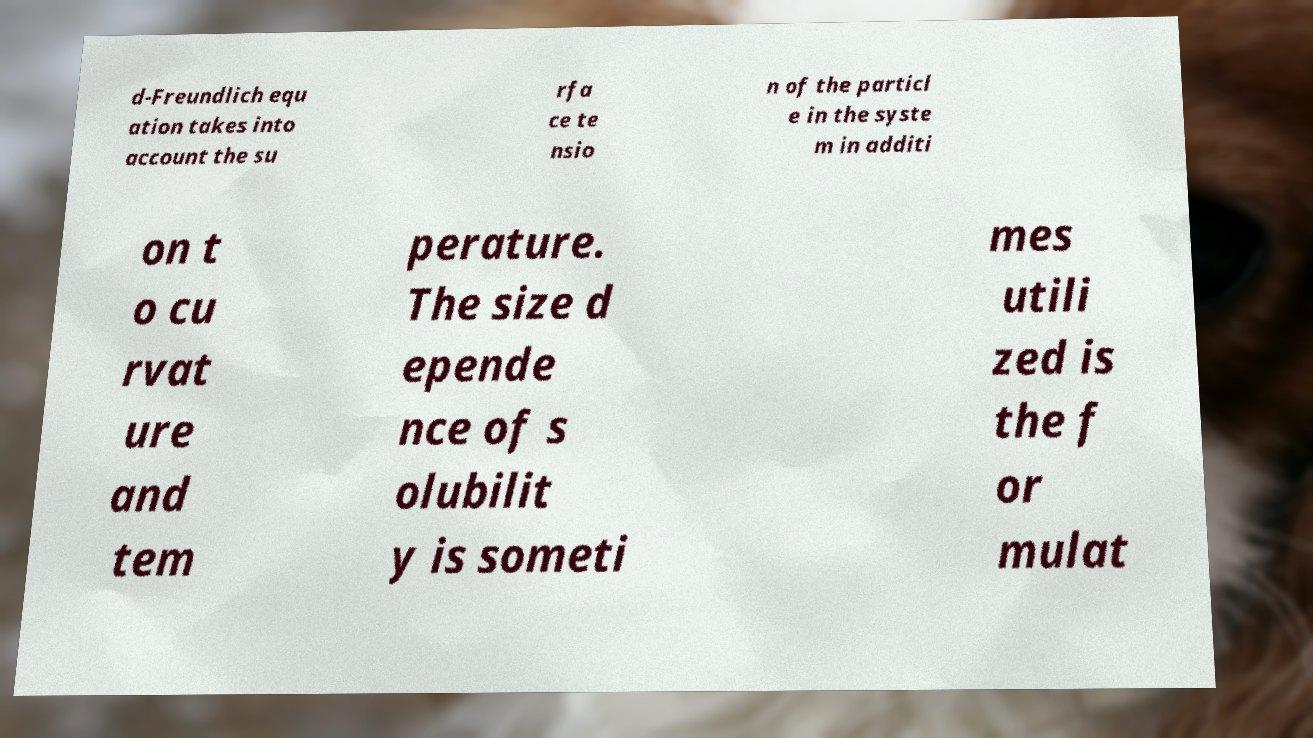Could you assist in decoding the text presented in this image and type it out clearly? d-Freundlich equ ation takes into account the su rfa ce te nsio n of the particl e in the syste m in additi on t o cu rvat ure and tem perature. The size d epende nce of s olubilit y is someti mes utili zed is the f or mulat 